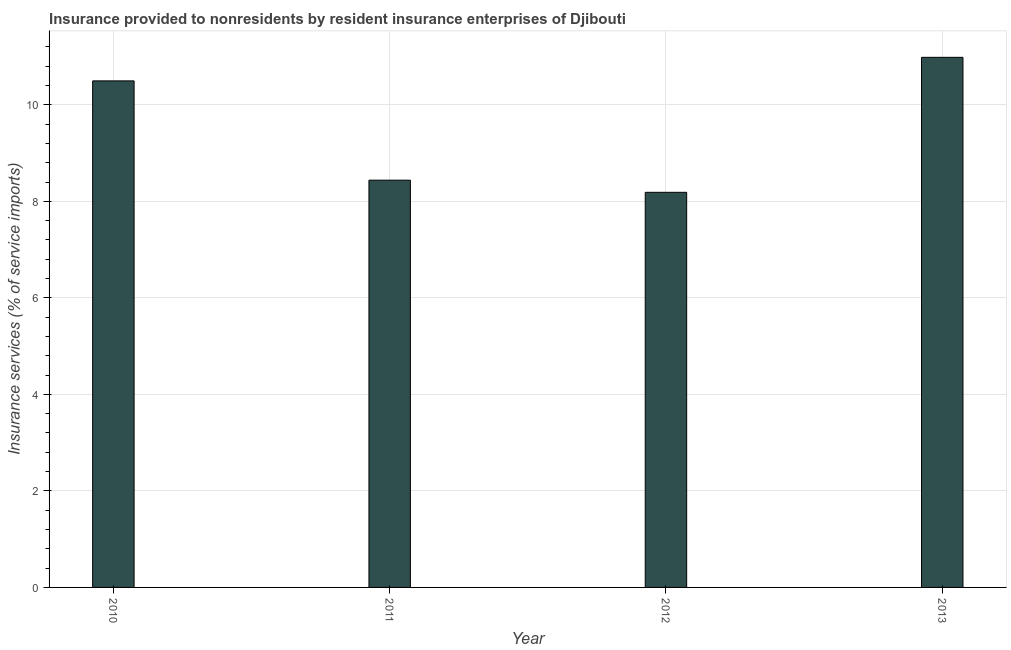Does the graph contain any zero values?
Your answer should be compact. No. What is the title of the graph?
Ensure brevity in your answer.  Insurance provided to nonresidents by resident insurance enterprises of Djibouti. What is the label or title of the X-axis?
Give a very brief answer. Year. What is the label or title of the Y-axis?
Your answer should be very brief. Insurance services (% of service imports). What is the insurance and financial services in 2010?
Make the answer very short. 10.5. Across all years, what is the maximum insurance and financial services?
Keep it short and to the point. 10.98. Across all years, what is the minimum insurance and financial services?
Offer a very short reply. 8.19. In which year was the insurance and financial services maximum?
Make the answer very short. 2013. What is the sum of the insurance and financial services?
Offer a terse response. 38.1. What is the difference between the insurance and financial services in 2012 and 2013?
Offer a very short reply. -2.8. What is the average insurance and financial services per year?
Make the answer very short. 9.53. What is the median insurance and financial services?
Provide a succinct answer. 9.47. What is the ratio of the insurance and financial services in 2011 to that in 2012?
Provide a succinct answer. 1.03. Is the insurance and financial services in 2012 less than that in 2013?
Your response must be concise. Yes. Is the difference between the insurance and financial services in 2012 and 2013 greater than the difference between any two years?
Give a very brief answer. Yes. What is the difference between the highest and the second highest insurance and financial services?
Ensure brevity in your answer.  0.49. Is the sum of the insurance and financial services in 2010 and 2013 greater than the maximum insurance and financial services across all years?
Provide a short and direct response. Yes. What is the difference between the highest and the lowest insurance and financial services?
Offer a very short reply. 2.8. Are all the bars in the graph horizontal?
Your response must be concise. No. What is the difference between two consecutive major ticks on the Y-axis?
Give a very brief answer. 2. Are the values on the major ticks of Y-axis written in scientific E-notation?
Make the answer very short. No. What is the Insurance services (% of service imports) in 2010?
Ensure brevity in your answer.  10.5. What is the Insurance services (% of service imports) of 2011?
Your response must be concise. 8.44. What is the Insurance services (% of service imports) in 2012?
Provide a succinct answer. 8.19. What is the Insurance services (% of service imports) in 2013?
Your answer should be very brief. 10.98. What is the difference between the Insurance services (% of service imports) in 2010 and 2011?
Make the answer very short. 2.06. What is the difference between the Insurance services (% of service imports) in 2010 and 2012?
Your answer should be compact. 2.31. What is the difference between the Insurance services (% of service imports) in 2010 and 2013?
Make the answer very short. -0.49. What is the difference between the Insurance services (% of service imports) in 2011 and 2012?
Your answer should be compact. 0.25. What is the difference between the Insurance services (% of service imports) in 2011 and 2013?
Offer a terse response. -2.55. What is the difference between the Insurance services (% of service imports) in 2012 and 2013?
Your answer should be compact. -2.8. What is the ratio of the Insurance services (% of service imports) in 2010 to that in 2011?
Your answer should be compact. 1.24. What is the ratio of the Insurance services (% of service imports) in 2010 to that in 2012?
Your response must be concise. 1.28. What is the ratio of the Insurance services (% of service imports) in 2010 to that in 2013?
Keep it short and to the point. 0.96. What is the ratio of the Insurance services (% of service imports) in 2011 to that in 2012?
Make the answer very short. 1.03. What is the ratio of the Insurance services (% of service imports) in 2011 to that in 2013?
Offer a very short reply. 0.77. What is the ratio of the Insurance services (% of service imports) in 2012 to that in 2013?
Your answer should be compact. 0.74. 